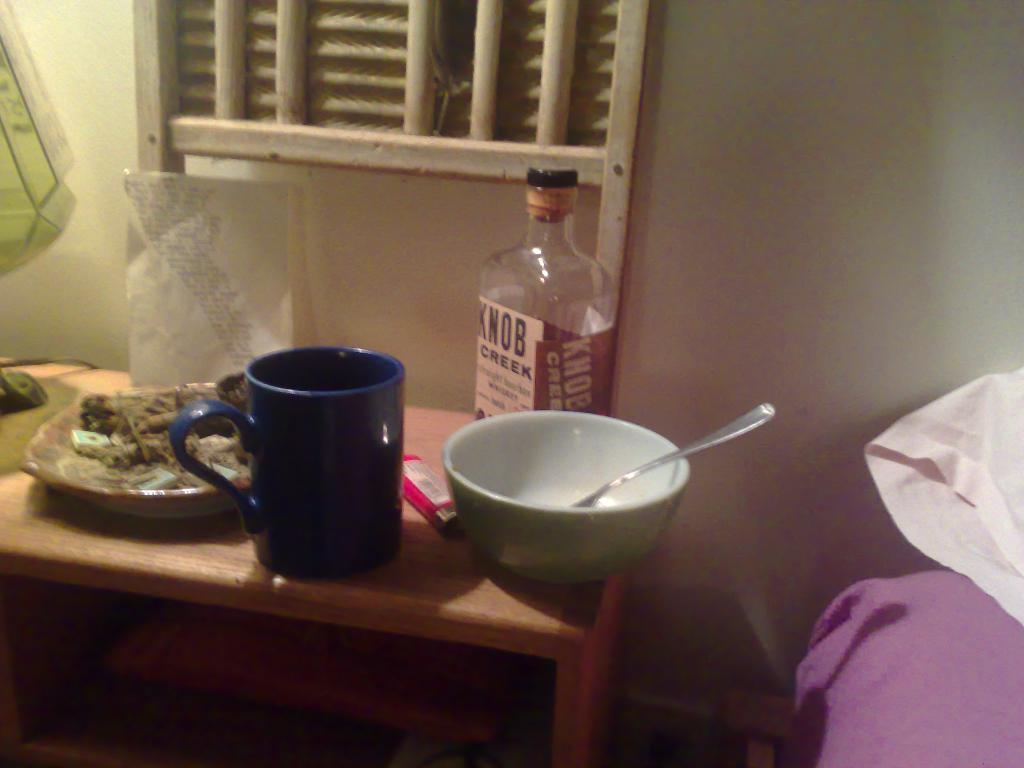What type of furniture is present in the image? There is a table in the image. Where is the table located in relation to the wall? The table is near a wall. What can be found on the table? There is a plate with food items, cups, bowls, spoons, a bottle, and a lighter on the table. What type of representative can be seen standing on the hill in the middle of the image? There is no representative or hill present in the image; it features a table with various items on it. 